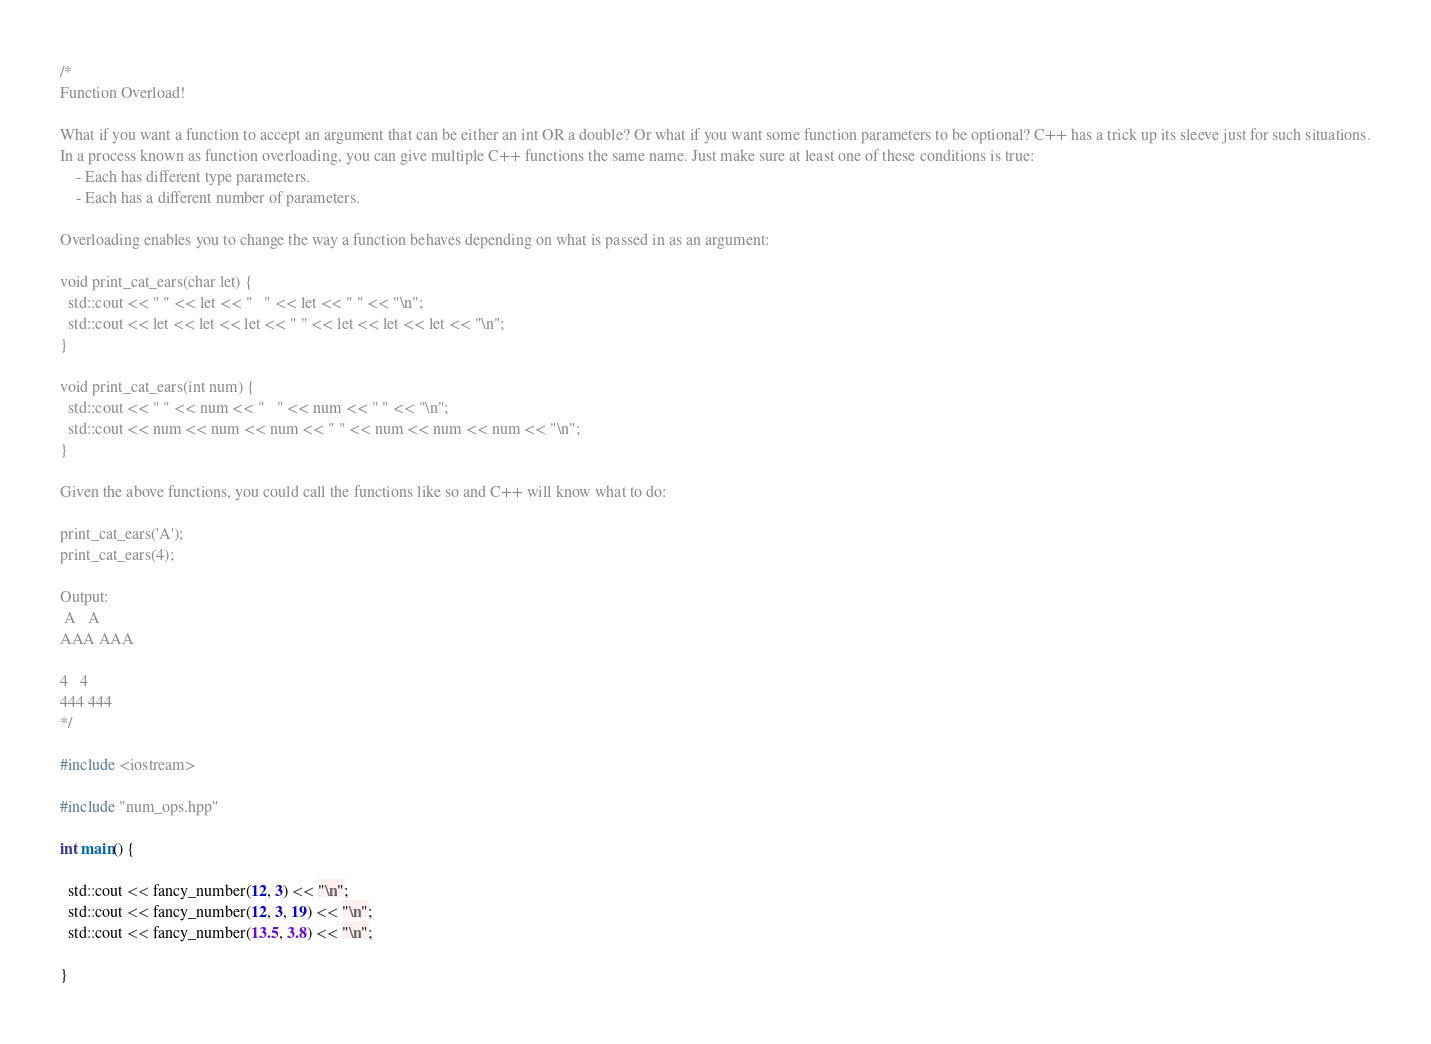<code> <loc_0><loc_0><loc_500><loc_500><_C++_>/*
Function Overload!

What if you want a function to accept an argument that can be either an int OR a double? Or what if you want some function parameters to be optional? C++ has a trick up its sleeve just for such situations.
In a process known as function overloading, you can give multiple C++ functions the same name. Just make sure at least one of these conditions is true:
    - Each has different type parameters.
    - Each has a different number of parameters.

Overloading enables you to change the way a function behaves depending on what is passed in as an argument:

void print_cat_ears(char let) {
  std::cout << " " << let << "   " << let << " " << "\n";
  std::cout << let << let << let << " " << let << let << let << "\n";
}

void print_cat_ears(int num) {
  std::cout << " " << num << "   " << num << " " << "\n";
  std::cout << num << num << num << " " << num << num << num << "\n";
}

Given the above functions, you could call the functions like so and C++ will know what to do:

print_cat_ears('A');
print_cat_ears(4);

Output:
 A   A 
AAA AAA

4   4
444 444
*/

#include <iostream>

#include "num_ops.hpp"

int main() {

  std::cout << fancy_number(12, 3) << "\n";
  std::cout << fancy_number(12, 3, 19) << "\n";
  std::cout << fancy_number(13.5, 3.8) << "\n";
  
}
</code> 